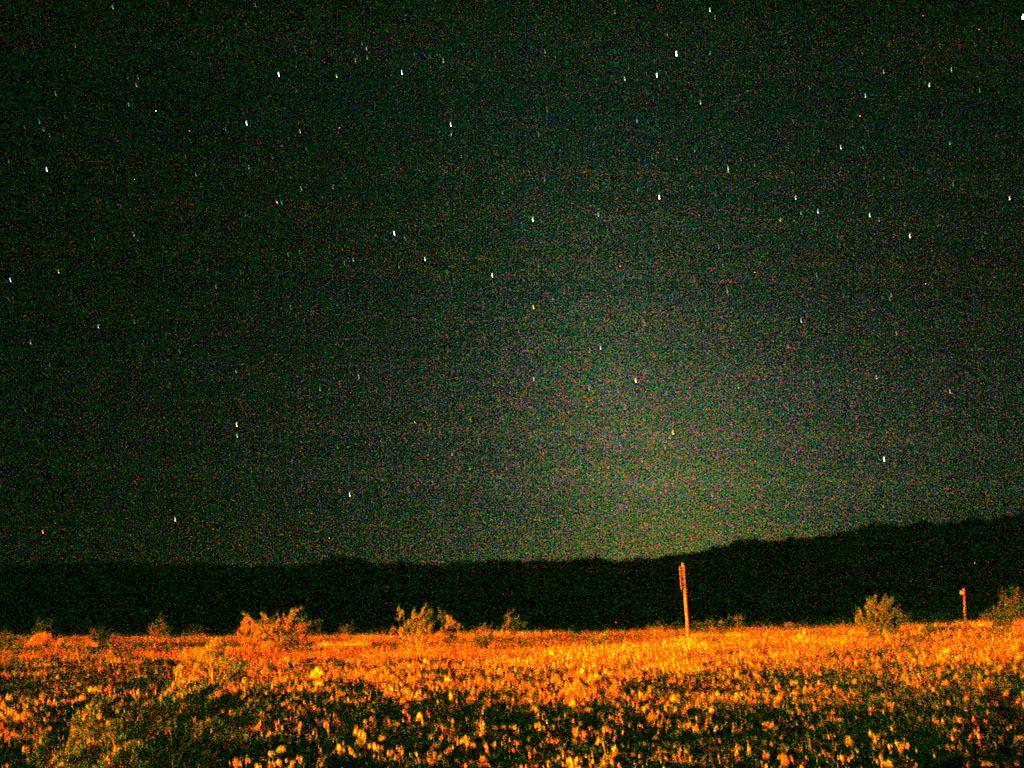Can you describe this image briefly? In the picture we can see a night view of a grass surface with plants and far away from it, we can see hills in the dark and behind it we can see a sky with stars. 